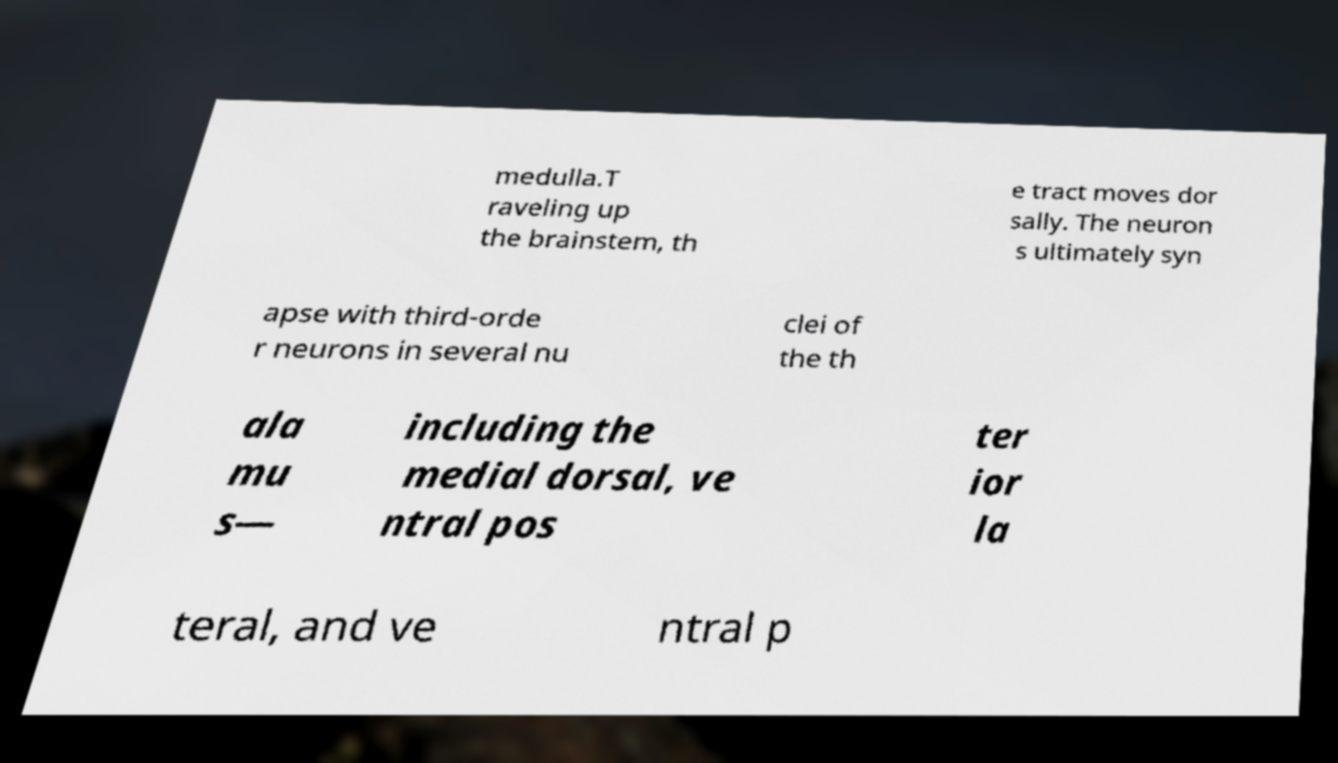There's text embedded in this image that I need extracted. Can you transcribe it verbatim? medulla.T raveling up the brainstem, th e tract moves dor sally. The neuron s ultimately syn apse with third-orde r neurons in several nu clei of the th ala mu s— including the medial dorsal, ve ntral pos ter ior la teral, and ve ntral p 